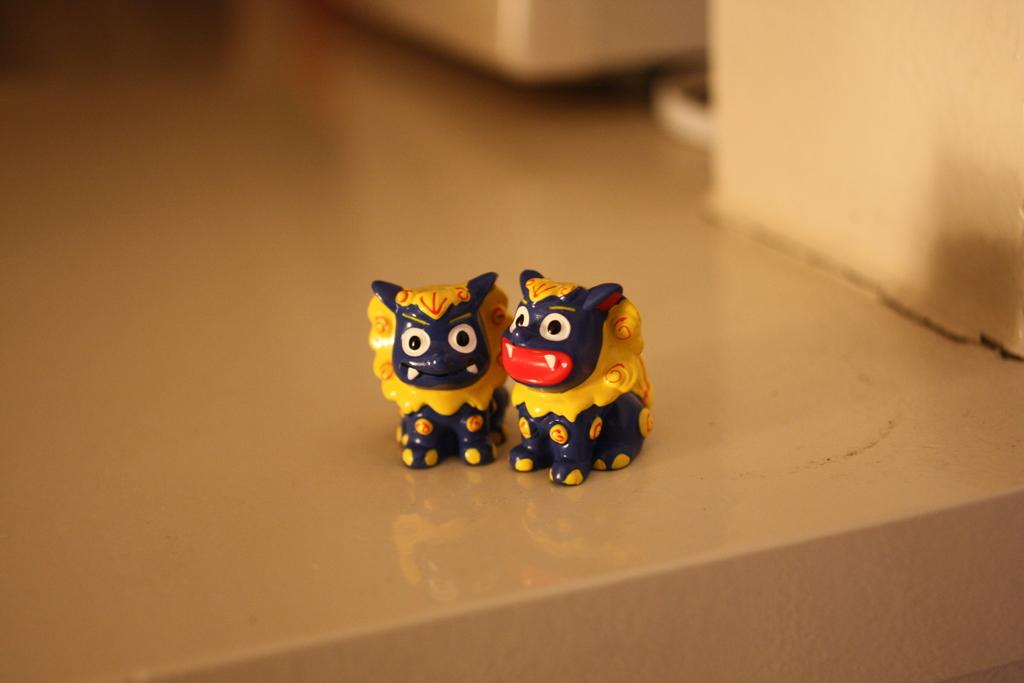How many dolls are present in the image? There are two dolls in the image. What colors are the dolls? One doll is blue in color, and the other doll is yellow in color. How many rabbits can be seen playing a game in the winter season in the image? There are no rabbits, games, or winter season depicted in the image; it features two dolls of different colors. 